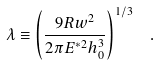Convert formula to latex. <formula><loc_0><loc_0><loc_500><loc_500>\lambda \equiv \left ( \frac { 9 R w ^ { 2 } } { 2 \pi E ^ { * 2 } h _ { 0 } ^ { 3 } } \right ) ^ { 1 / 3 } \ \ .</formula> 